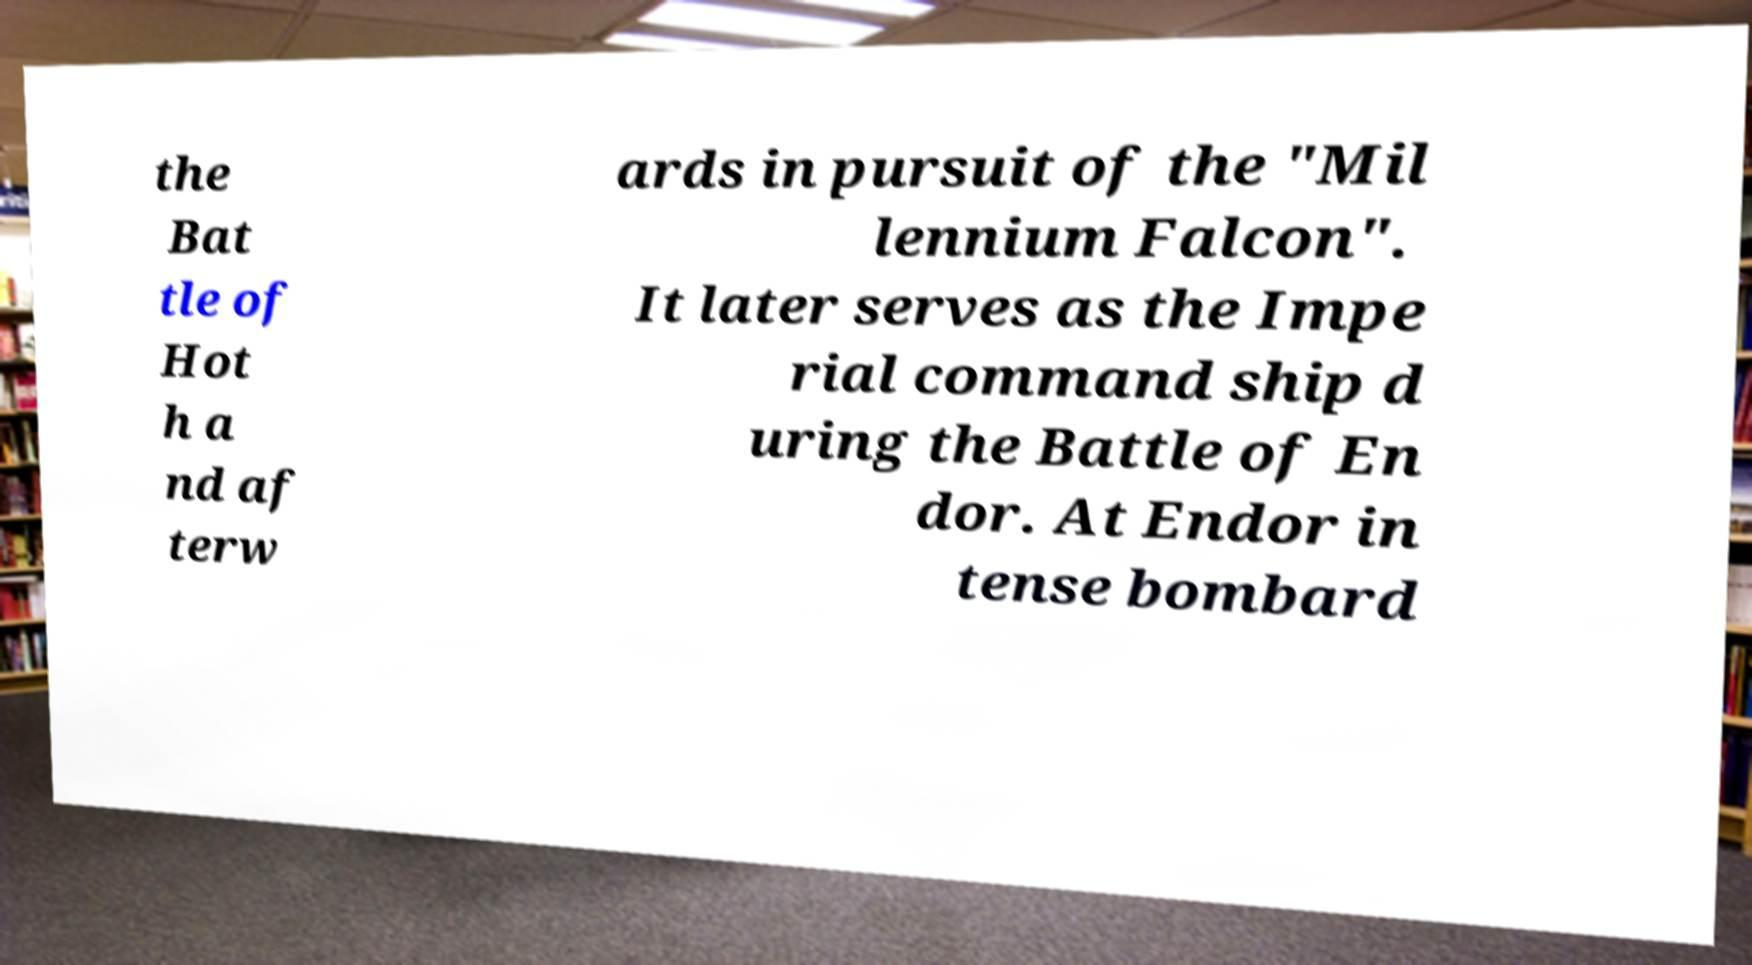Please read and relay the text visible in this image. What does it say? the Bat tle of Hot h a nd af terw ards in pursuit of the "Mil lennium Falcon". It later serves as the Impe rial command ship d uring the Battle of En dor. At Endor in tense bombard 